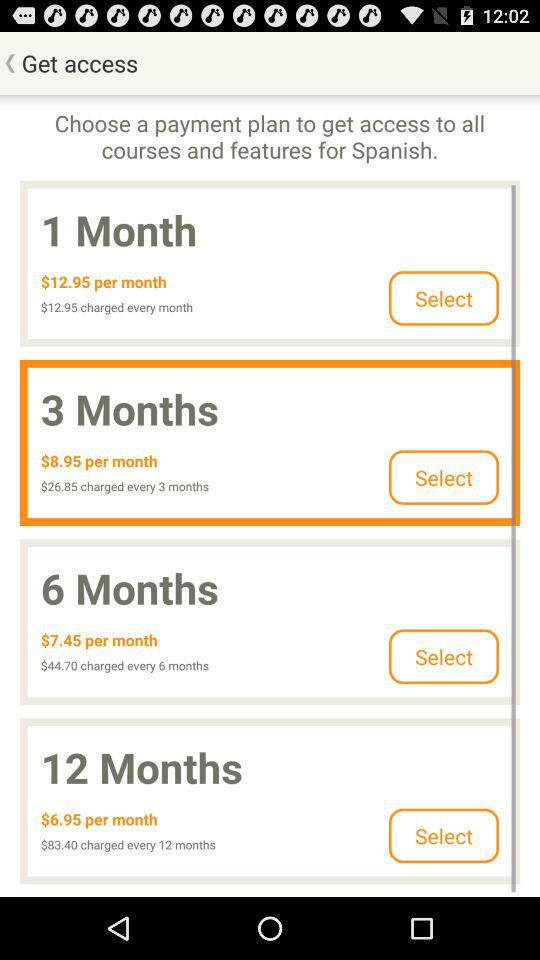How many more months does the 12-month plan cover than the 6-month plan?
Answer the question using a single word or phrase. 6 